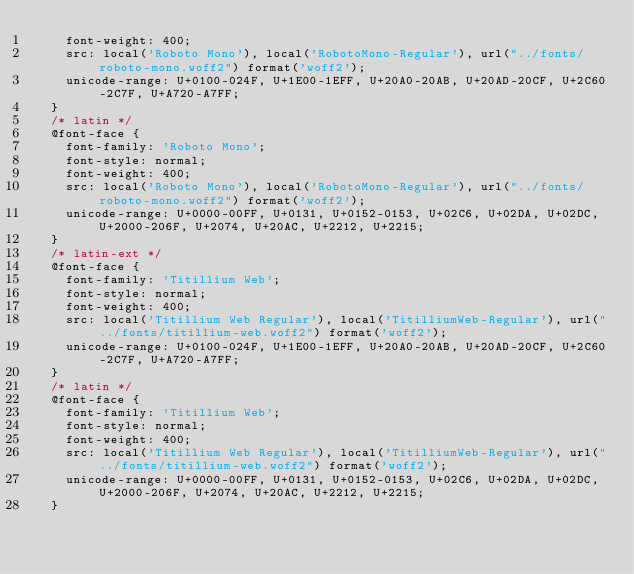<code> <loc_0><loc_0><loc_500><loc_500><_CSS_>    font-weight: 400;
    src: local('Roboto Mono'), local('RobotoMono-Regular'), url("../fonts/roboto-mono.woff2") format('woff2');
    unicode-range: U+0100-024F, U+1E00-1EFF, U+20A0-20AB, U+20AD-20CF, U+2C60-2C7F, U+A720-A7FF;
  }
  /* latin */
  @font-face {
    font-family: 'Roboto Mono';
    font-style: normal;
    font-weight: 400;
    src: local('Roboto Mono'), local('RobotoMono-Regular'), url("../fonts/roboto-mono.woff2") format('woff2');
    unicode-range: U+0000-00FF, U+0131, U+0152-0153, U+02C6, U+02DA, U+02DC, U+2000-206F, U+2074, U+20AC, U+2212, U+2215;
  }
  /* latin-ext */
  @font-face {
    font-family: 'Titillium Web';
    font-style: normal;
    font-weight: 400;
    src: local('Titillium Web Regular'), local('TitilliumWeb-Regular'), url("../fonts/titillium-web.woff2") format('woff2');
    unicode-range: U+0100-024F, U+1E00-1EFF, U+20A0-20AB, U+20AD-20CF, U+2C60-2C7F, U+A720-A7FF;
  }
  /* latin */
  @font-face {
    font-family: 'Titillium Web';
    font-style: normal;
    font-weight: 400;
    src: local('Titillium Web Regular'), local('TitilliumWeb-Regular'), url("../fonts/titillium-web.woff2") format('woff2');
    unicode-range: U+0000-00FF, U+0131, U+0152-0153, U+02C6, U+02DA, U+02DC, U+2000-206F, U+2074, U+20AC, U+2212, U+2215;
  }</code> 